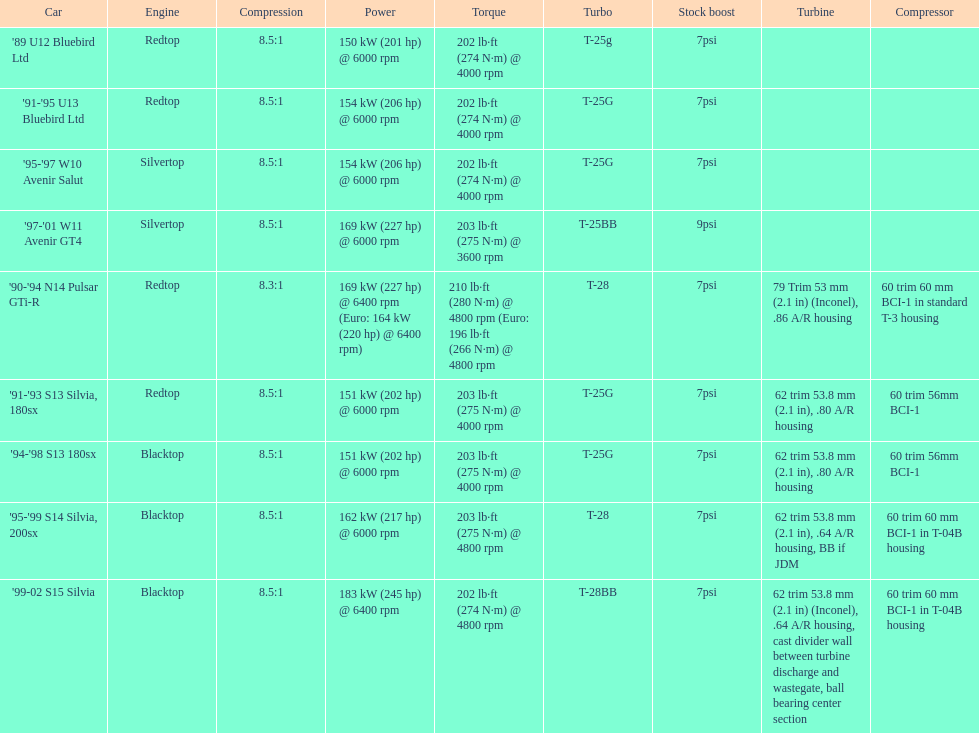Which engine possesses the lowest compression ratio? '90-'94 N14 Pulsar GTi-R. 